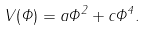Convert formula to latex. <formula><loc_0><loc_0><loc_500><loc_500>V ( \Phi ) = a \Phi ^ { 2 } + c \Phi ^ { 4 } .</formula> 